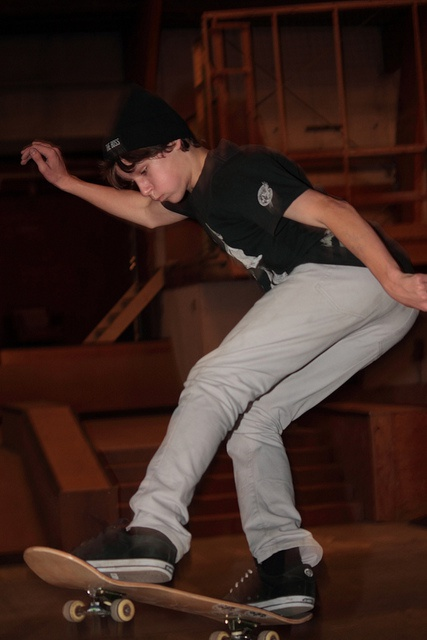Describe the objects in this image and their specific colors. I can see people in black, darkgray, and gray tones and skateboard in black, maroon, brown, and gray tones in this image. 